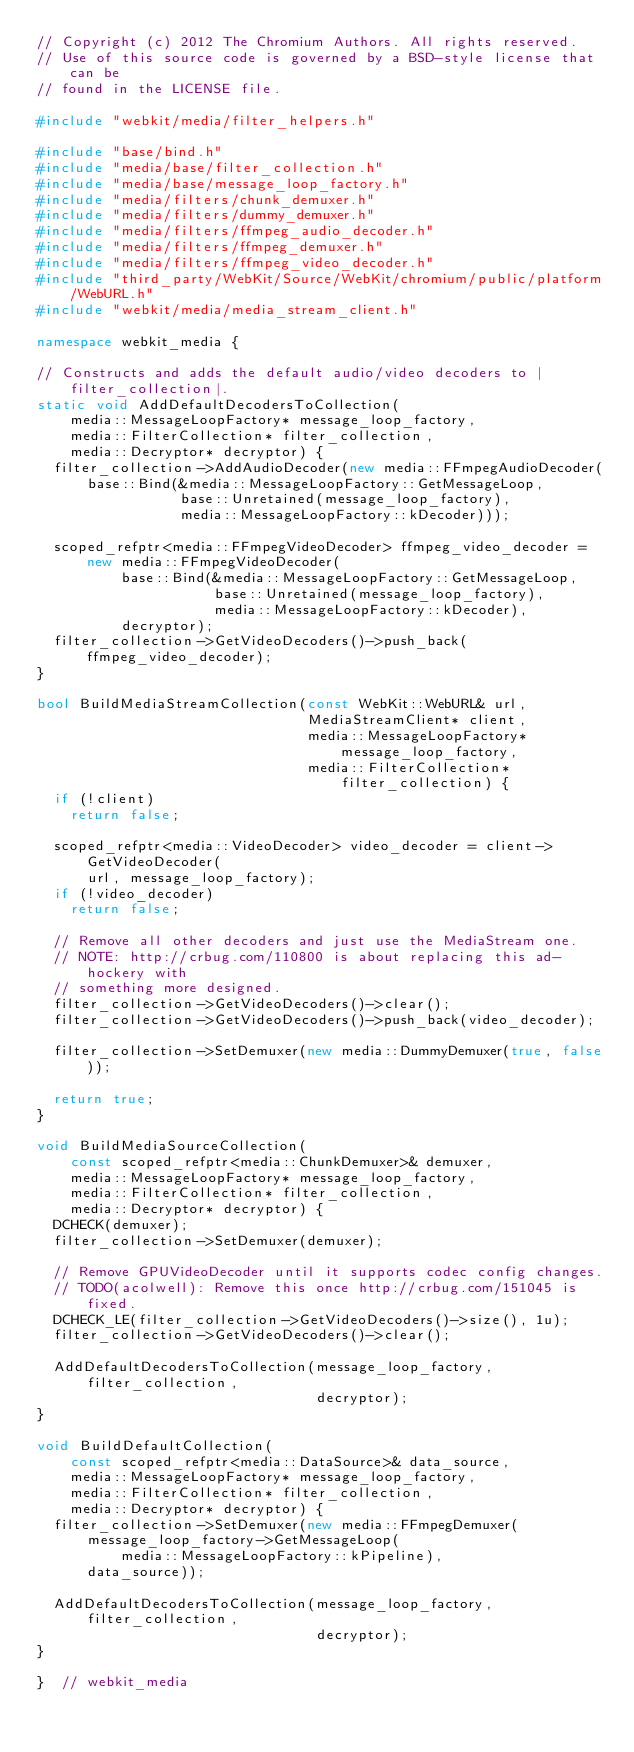Convert code to text. <code><loc_0><loc_0><loc_500><loc_500><_C++_>// Copyright (c) 2012 The Chromium Authors. All rights reserved.
// Use of this source code is governed by a BSD-style license that can be
// found in the LICENSE file.

#include "webkit/media/filter_helpers.h"

#include "base/bind.h"
#include "media/base/filter_collection.h"
#include "media/base/message_loop_factory.h"
#include "media/filters/chunk_demuxer.h"
#include "media/filters/dummy_demuxer.h"
#include "media/filters/ffmpeg_audio_decoder.h"
#include "media/filters/ffmpeg_demuxer.h"
#include "media/filters/ffmpeg_video_decoder.h"
#include "third_party/WebKit/Source/WebKit/chromium/public/platform/WebURL.h"
#include "webkit/media/media_stream_client.h"

namespace webkit_media {

// Constructs and adds the default audio/video decoders to |filter_collection|.
static void AddDefaultDecodersToCollection(
    media::MessageLoopFactory* message_loop_factory,
    media::FilterCollection* filter_collection,
    media::Decryptor* decryptor) {
  filter_collection->AddAudioDecoder(new media::FFmpegAudioDecoder(
      base::Bind(&media::MessageLoopFactory::GetMessageLoop,
                 base::Unretained(message_loop_factory),
                 media::MessageLoopFactory::kDecoder)));

  scoped_refptr<media::FFmpegVideoDecoder> ffmpeg_video_decoder =
      new media::FFmpegVideoDecoder(
          base::Bind(&media::MessageLoopFactory::GetMessageLoop,
                     base::Unretained(message_loop_factory),
                     media::MessageLoopFactory::kDecoder),
          decryptor);
  filter_collection->GetVideoDecoders()->push_back(ffmpeg_video_decoder);
}

bool BuildMediaStreamCollection(const WebKit::WebURL& url,
                                MediaStreamClient* client,
                                media::MessageLoopFactory* message_loop_factory,
                                media::FilterCollection* filter_collection) {
  if (!client)
    return false;

  scoped_refptr<media::VideoDecoder> video_decoder = client->GetVideoDecoder(
      url, message_loop_factory);
  if (!video_decoder)
    return false;

  // Remove all other decoders and just use the MediaStream one.
  // NOTE: http://crbug.com/110800 is about replacing this ad-hockery with
  // something more designed.
  filter_collection->GetVideoDecoders()->clear();
  filter_collection->GetVideoDecoders()->push_back(video_decoder);

  filter_collection->SetDemuxer(new media::DummyDemuxer(true, false));

  return true;
}

void BuildMediaSourceCollection(
    const scoped_refptr<media::ChunkDemuxer>& demuxer,
    media::MessageLoopFactory* message_loop_factory,
    media::FilterCollection* filter_collection,
    media::Decryptor* decryptor) {
  DCHECK(demuxer);
  filter_collection->SetDemuxer(demuxer);

  // Remove GPUVideoDecoder until it supports codec config changes.
  // TODO(acolwell): Remove this once http://crbug.com/151045 is fixed.
  DCHECK_LE(filter_collection->GetVideoDecoders()->size(), 1u);
  filter_collection->GetVideoDecoders()->clear();

  AddDefaultDecodersToCollection(message_loop_factory, filter_collection,
                                 decryptor);
}

void BuildDefaultCollection(
    const scoped_refptr<media::DataSource>& data_source,
    media::MessageLoopFactory* message_loop_factory,
    media::FilterCollection* filter_collection,
    media::Decryptor* decryptor) {
  filter_collection->SetDemuxer(new media::FFmpegDemuxer(
      message_loop_factory->GetMessageLoop(
          media::MessageLoopFactory::kPipeline),
      data_source));

  AddDefaultDecodersToCollection(message_loop_factory, filter_collection,
                                 decryptor);
}

}  // webkit_media
</code> 